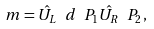Convert formula to latex. <formula><loc_0><loc_0><loc_500><loc_500>m = \hat { U _ { L } } \ d \ P _ { 1 } \hat { U _ { R } } \ P _ { 2 } \, ,</formula> 